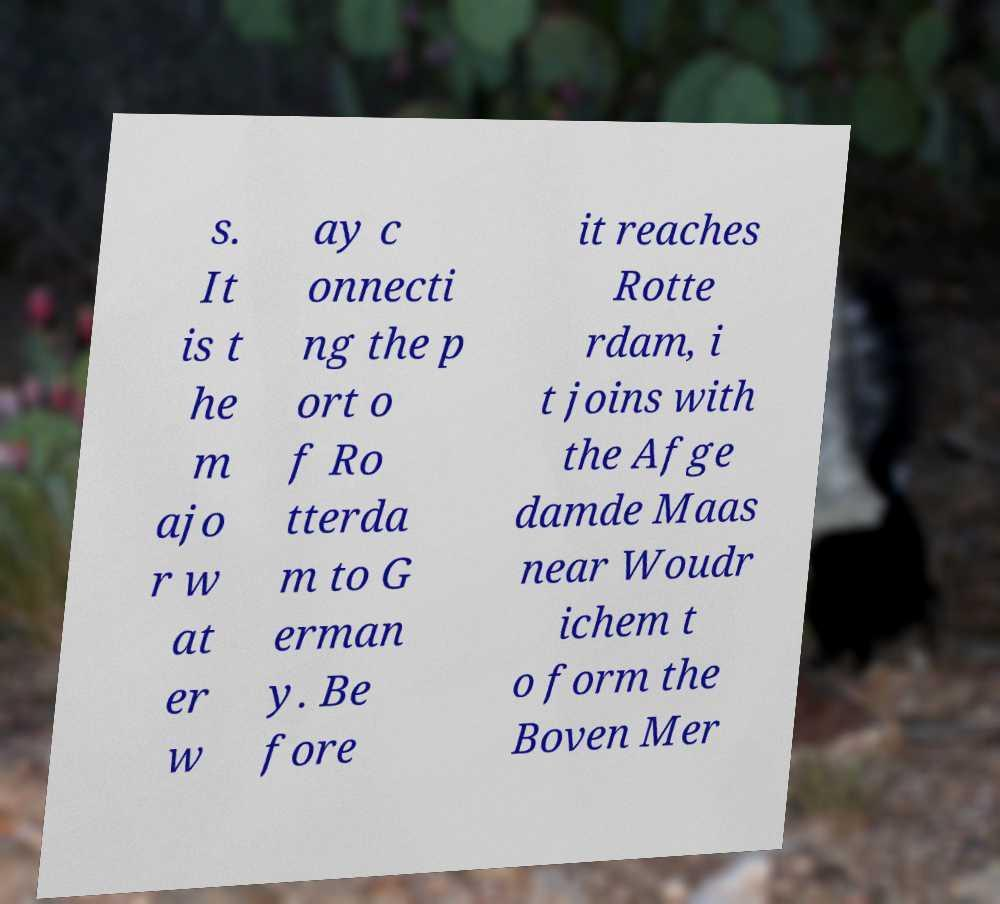Please identify and transcribe the text found in this image. s. It is t he m ajo r w at er w ay c onnecti ng the p ort o f Ro tterda m to G erman y. Be fore it reaches Rotte rdam, i t joins with the Afge damde Maas near Woudr ichem t o form the Boven Mer 